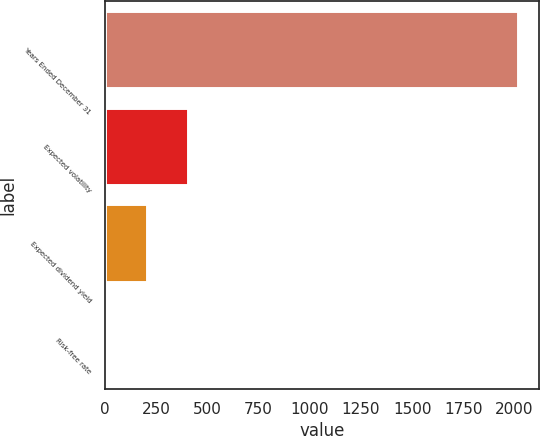Convert chart to OTSL. <chart><loc_0><loc_0><loc_500><loc_500><bar_chart><fcel>Years Ended December 31<fcel>Expected volatility<fcel>Expected dividend yield<fcel>Risk-free rate<nl><fcel>2017<fcel>404.6<fcel>203.05<fcel>1.5<nl></chart> 